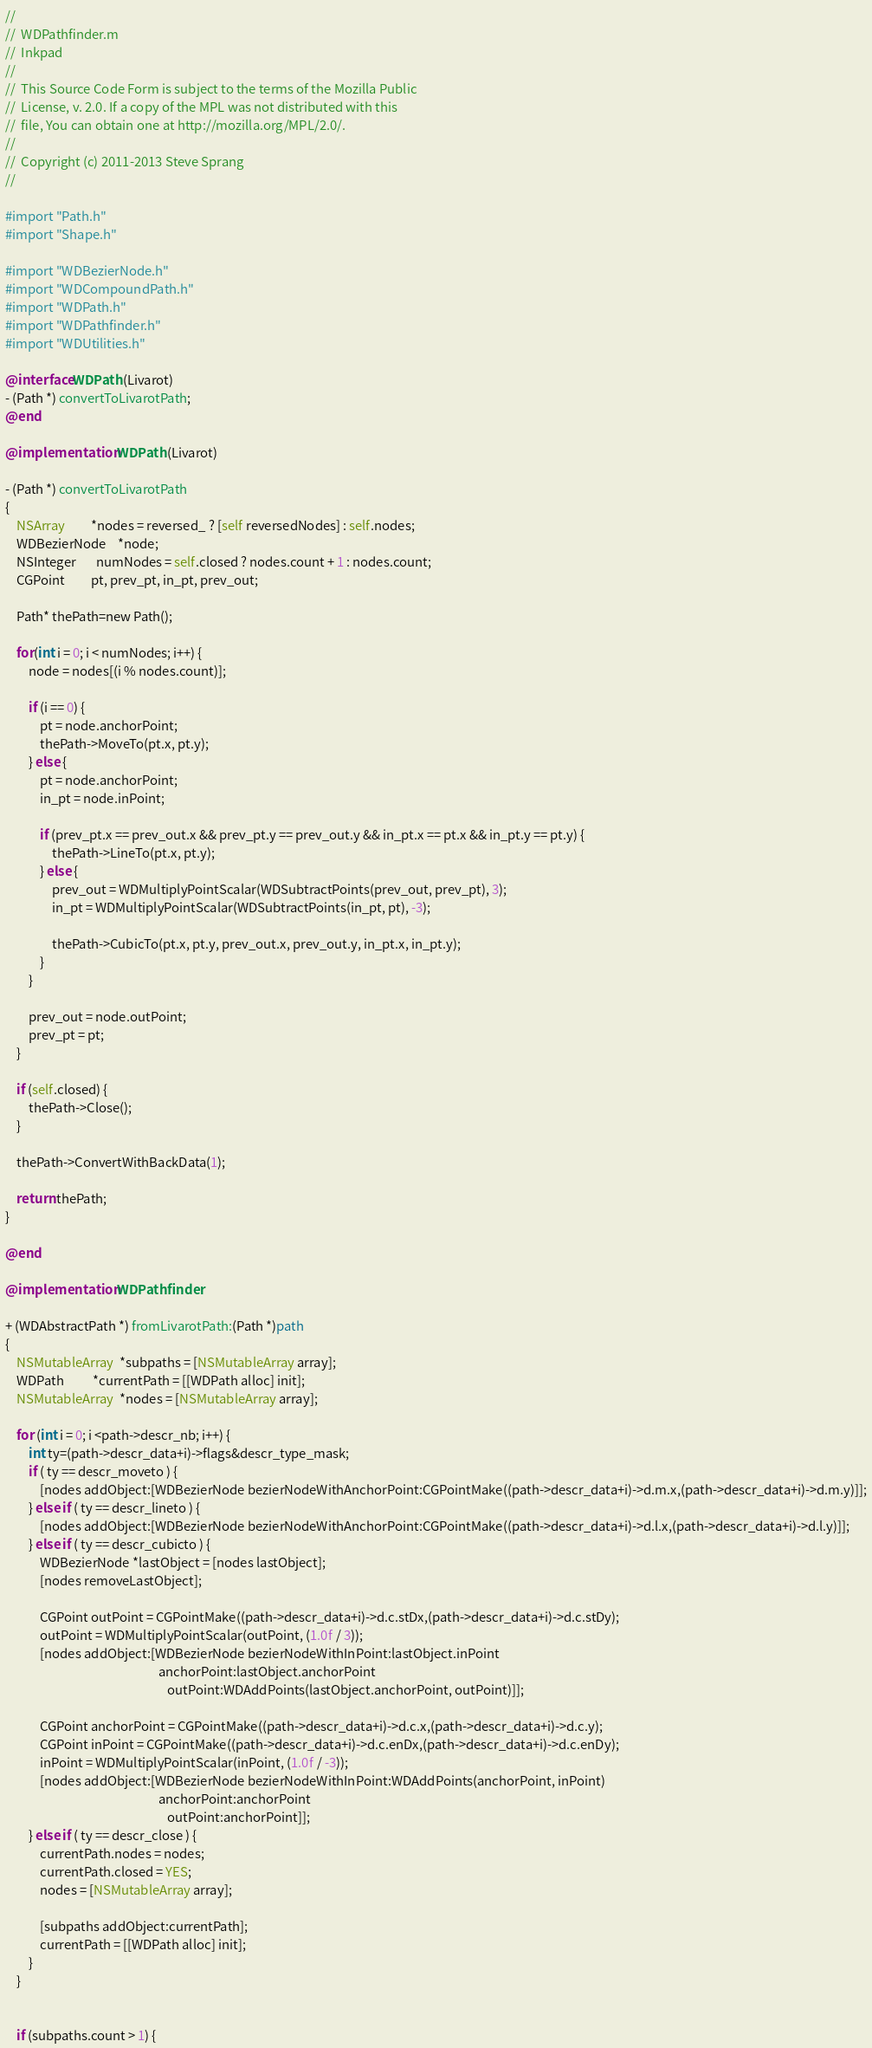<code> <loc_0><loc_0><loc_500><loc_500><_ObjectiveC_>//
//  WDPathfinder.m
//  Inkpad
//
//  This Source Code Form is subject to the terms of the Mozilla Public
//  License, v. 2.0. If a copy of the MPL was not distributed with this
//  file, You can obtain one at http://mozilla.org/MPL/2.0/.
//
//  Copyright (c) 2011-2013 Steve Sprang
//

#import "Path.h"
#import "Shape.h"

#import "WDBezierNode.h"
#import "WDCompoundPath.h"
#import "WDPath.h"
#import "WDPathfinder.h"
#import "WDUtilities.h"

@interface WDPath (Livarot)
- (Path *) convertToLivarotPath;
@end

@implementation WDPath (Livarot)

- (Path *) convertToLivarotPath
{    
    NSArray         *nodes = reversed_ ? [self reversedNodes] : self.nodes;
    WDBezierNode    *node;
    NSInteger       numNodes = self.closed ? nodes.count + 1 : nodes.count;
    CGPoint         pt, prev_pt, in_pt, prev_out;
     
    Path* thePath=new Path();
    
    for(int i = 0; i < numNodes; i++) {
        node = nodes[(i % nodes.count)];
        
        if (i == 0) {
            pt = node.anchorPoint;
            thePath->MoveTo(pt.x, pt.y);
        } else {
            pt = node.anchorPoint;
            in_pt = node.inPoint;
            
            if (prev_pt.x == prev_out.x && prev_pt.y == prev_out.y && in_pt.x == pt.x && in_pt.y == pt.y) {
            	thePath->LineTo(pt.x, pt.y);
            } else {
                prev_out = WDMultiplyPointScalar(WDSubtractPoints(prev_out, prev_pt), 3);
                in_pt = WDMultiplyPointScalar(WDSubtractPoints(in_pt, pt), -3);
                
                thePath->CubicTo(pt.x, pt.y, prev_out.x, prev_out.y, in_pt.x, in_pt.y);
            }       
        }
        
        prev_out = node.outPoint;
        prev_pt = pt; 
    }
    
    if (self.closed) {
        thePath->Close();
    }
    
    thePath->ConvertWithBackData(1);
    
    return thePath;
}

@end

@implementation WDPathfinder

+ (WDAbstractPath *) fromLivarotPath:(Path *)path
{
    NSMutableArray  *subpaths = [NSMutableArray array];
    WDPath          *currentPath = [[WDPath alloc] init];
    NSMutableArray  *nodes = [NSMutableArray array];
    
	for (int i = 0; i <path->descr_nb; i++) {
		int ty=(path->descr_data+i)->flags&descr_type_mask;
		if ( ty == descr_moveto ) {
            [nodes addObject:[WDBezierNode bezierNodeWithAnchorPoint:CGPointMake((path->descr_data+i)->d.m.x,(path->descr_data+i)->d.m.y)]];
		} else if ( ty == descr_lineto ) {
            [nodes addObject:[WDBezierNode bezierNodeWithAnchorPoint:CGPointMake((path->descr_data+i)->d.l.x,(path->descr_data+i)->d.l.y)]];
		} else if ( ty == descr_cubicto ) {
            WDBezierNode *lastObject = [nodes lastObject];
            [nodes removeLastObject];
            
            CGPoint outPoint = CGPointMake((path->descr_data+i)->d.c.stDx,(path->descr_data+i)->d.c.stDy);
            outPoint = WDMultiplyPointScalar(outPoint, (1.0f / 3));
            [nodes addObject:[WDBezierNode bezierNodeWithInPoint:lastObject.inPoint
                                                     anchorPoint:lastObject.anchorPoint
                                                        outPoint:WDAddPoints(lastObject.anchorPoint, outPoint)]];
            
            CGPoint anchorPoint = CGPointMake((path->descr_data+i)->d.c.x,(path->descr_data+i)->d.c.y);
            CGPoint inPoint = CGPointMake((path->descr_data+i)->d.c.enDx,(path->descr_data+i)->d.c.enDy);
            inPoint = WDMultiplyPointScalar(inPoint, (1.0f / -3));
            [nodes addObject:[WDBezierNode bezierNodeWithInPoint:WDAddPoints(anchorPoint, inPoint)
                                                     anchorPoint:anchorPoint
                                                        outPoint:anchorPoint]];
		} else if ( ty == descr_close ) {
            currentPath.nodes = nodes;
            currentPath.closed = YES;
            nodes = [NSMutableArray array];
            
            [subpaths addObject:currentPath];
            currentPath = [[WDPath alloc] init];
		}
	}
    
    
    if (subpaths.count > 1) {</code> 